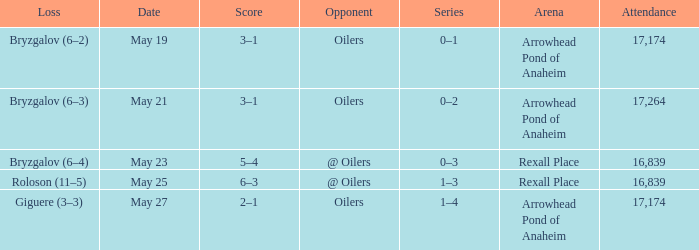How much attendance has a Loss of roloson (11–5)? 16839.0. 